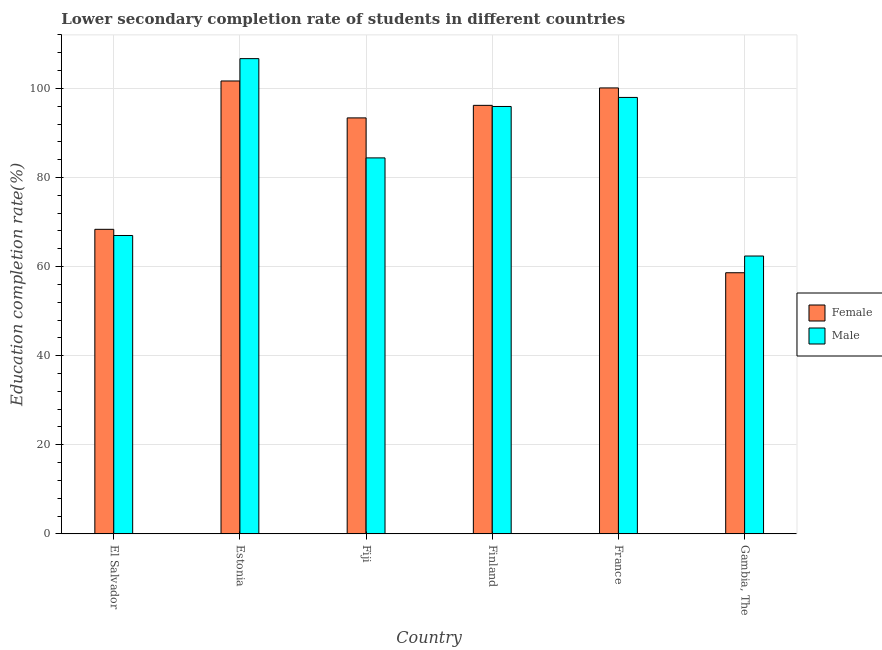How many groups of bars are there?
Offer a terse response. 6. Are the number of bars on each tick of the X-axis equal?
Your answer should be very brief. Yes. How many bars are there on the 1st tick from the left?
Ensure brevity in your answer.  2. What is the label of the 5th group of bars from the left?
Provide a succinct answer. France. What is the education completion rate of female students in France?
Make the answer very short. 100.12. Across all countries, what is the maximum education completion rate of male students?
Your response must be concise. 106.69. Across all countries, what is the minimum education completion rate of male students?
Make the answer very short. 62.38. In which country was the education completion rate of male students maximum?
Keep it short and to the point. Estonia. In which country was the education completion rate of male students minimum?
Make the answer very short. Gambia, The. What is the total education completion rate of female students in the graph?
Make the answer very short. 518.38. What is the difference between the education completion rate of male students in Finland and that in France?
Give a very brief answer. -2.03. What is the difference between the education completion rate of male students in Estonia and the education completion rate of female students in Finland?
Offer a terse response. 10.49. What is the average education completion rate of male students per country?
Ensure brevity in your answer.  85.73. What is the difference between the education completion rate of female students and education completion rate of male students in Fiji?
Ensure brevity in your answer.  8.98. What is the ratio of the education completion rate of male students in El Salvador to that in Estonia?
Keep it short and to the point. 0.63. Is the difference between the education completion rate of male students in Fiji and France greater than the difference between the education completion rate of female students in Fiji and France?
Make the answer very short. No. What is the difference between the highest and the second highest education completion rate of female students?
Provide a succinct answer. 1.56. What is the difference between the highest and the lowest education completion rate of female students?
Keep it short and to the point. 43.05. Is the sum of the education completion rate of male students in Fiji and Gambia, The greater than the maximum education completion rate of female students across all countries?
Make the answer very short. Yes. What does the 2nd bar from the left in France represents?
Offer a very short reply. Male. How many bars are there?
Provide a succinct answer. 12. Are all the bars in the graph horizontal?
Offer a terse response. No. How many countries are there in the graph?
Offer a terse response. 6. Are the values on the major ticks of Y-axis written in scientific E-notation?
Make the answer very short. No. Does the graph contain grids?
Your answer should be compact. Yes. Where does the legend appear in the graph?
Your answer should be very brief. Center right. How many legend labels are there?
Provide a short and direct response. 2. What is the title of the graph?
Provide a succinct answer. Lower secondary completion rate of students in different countries. What is the label or title of the X-axis?
Your answer should be very brief. Country. What is the label or title of the Y-axis?
Give a very brief answer. Education completion rate(%). What is the Education completion rate(%) in Female in El Salvador?
Offer a very short reply. 68.37. What is the Education completion rate(%) of Male in El Salvador?
Your answer should be very brief. 66.99. What is the Education completion rate(%) in Female in Estonia?
Offer a very short reply. 101.68. What is the Education completion rate(%) of Male in Estonia?
Ensure brevity in your answer.  106.69. What is the Education completion rate(%) in Female in Fiji?
Provide a succinct answer. 93.39. What is the Education completion rate(%) of Male in Fiji?
Offer a very short reply. 84.41. What is the Education completion rate(%) of Female in Finland?
Your answer should be compact. 96.21. What is the Education completion rate(%) of Male in Finland?
Your answer should be very brief. 95.95. What is the Education completion rate(%) in Female in France?
Make the answer very short. 100.12. What is the Education completion rate(%) in Male in France?
Offer a terse response. 97.98. What is the Education completion rate(%) of Female in Gambia, The?
Your answer should be very brief. 58.62. What is the Education completion rate(%) in Male in Gambia, The?
Offer a very short reply. 62.38. Across all countries, what is the maximum Education completion rate(%) in Female?
Your answer should be very brief. 101.68. Across all countries, what is the maximum Education completion rate(%) of Male?
Offer a very short reply. 106.69. Across all countries, what is the minimum Education completion rate(%) of Female?
Keep it short and to the point. 58.62. Across all countries, what is the minimum Education completion rate(%) of Male?
Your answer should be very brief. 62.38. What is the total Education completion rate(%) in Female in the graph?
Give a very brief answer. 518.38. What is the total Education completion rate(%) in Male in the graph?
Make the answer very short. 514.4. What is the difference between the Education completion rate(%) in Female in El Salvador and that in Estonia?
Your response must be concise. -33.3. What is the difference between the Education completion rate(%) of Male in El Salvador and that in Estonia?
Make the answer very short. -39.71. What is the difference between the Education completion rate(%) in Female in El Salvador and that in Fiji?
Provide a succinct answer. -25.01. What is the difference between the Education completion rate(%) in Male in El Salvador and that in Fiji?
Provide a succinct answer. -17.42. What is the difference between the Education completion rate(%) in Female in El Salvador and that in Finland?
Ensure brevity in your answer.  -27.83. What is the difference between the Education completion rate(%) of Male in El Salvador and that in Finland?
Offer a terse response. -28.96. What is the difference between the Education completion rate(%) in Female in El Salvador and that in France?
Your response must be concise. -31.74. What is the difference between the Education completion rate(%) of Male in El Salvador and that in France?
Make the answer very short. -31. What is the difference between the Education completion rate(%) in Female in El Salvador and that in Gambia, The?
Provide a succinct answer. 9.75. What is the difference between the Education completion rate(%) in Male in El Salvador and that in Gambia, The?
Your answer should be very brief. 4.61. What is the difference between the Education completion rate(%) of Female in Estonia and that in Fiji?
Ensure brevity in your answer.  8.29. What is the difference between the Education completion rate(%) of Male in Estonia and that in Fiji?
Ensure brevity in your answer.  22.28. What is the difference between the Education completion rate(%) in Female in Estonia and that in Finland?
Your answer should be compact. 5.47. What is the difference between the Education completion rate(%) of Male in Estonia and that in Finland?
Your answer should be very brief. 10.74. What is the difference between the Education completion rate(%) in Female in Estonia and that in France?
Offer a terse response. 1.56. What is the difference between the Education completion rate(%) of Male in Estonia and that in France?
Provide a succinct answer. 8.71. What is the difference between the Education completion rate(%) in Female in Estonia and that in Gambia, The?
Your response must be concise. 43.05. What is the difference between the Education completion rate(%) of Male in Estonia and that in Gambia, The?
Your response must be concise. 44.32. What is the difference between the Education completion rate(%) in Female in Fiji and that in Finland?
Offer a terse response. -2.82. What is the difference between the Education completion rate(%) of Male in Fiji and that in Finland?
Offer a terse response. -11.54. What is the difference between the Education completion rate(%) of Female in Fiji and that in France?
Your answer should be compact. -6.73. What is the difference between the Education completion rate(%) of Male in Fiji and that in France?
Give a very brief answer. -13.58. What is the difference between the Education completion rate(%) in Female in Fiji and that in Gambia, The?
Give a very brief answer. 34.76. What is the difference between the Education completion rate(%) in Male in Fiji and that in Gambia, The?
Provide a succinct answer. 22.03. What is the difference between the Education completion rate(%) of Female in Finland and that in France?
Give a very brief answer. -3.91. What is the difference between the Education completion rate(%) in Male in Finland and that in France?
Offer a very short reply. -2.03. What is the difference between the Education completion rate(%) in Female in Finland and that in Gambia, The?
Make the answer very short. 37.58. What is the difference between the Education completion rate(%) of Male in Finland and that in Gambia, The?
Your response must be concise. 33.58. What is the difference between the Education completion rate(%) of Female in France and that in Gambia, The?
Provide a short and direct response. 41.49. What is the difference between the Education completion rate(%) in Male in France and that in Gambia, The?
Offer a terse response. 35.61. What is the difference between the Education completion rate(%) in Female in El Salvador and the Education completion rate(%) in Male in Estonia?
Provide a short and direct response. -38.32. What is the difference between the Education completion rate(%) of Female in El Salvador and the Education completion rate(%) of Male in Fiji?
Your answer should be compact. -16.04. What is the difference between the Education completion rate(%) in Female in El Salvador and the Education completion rate(%) in Male in Finland?
Give a very brief answer. -27.58. What is the difference between the Education completion rate(%) in Female in El Salvador and the Education completion rate(%) in Male in France?
Offer a terse response. -29.61. What is the difference between the Education completion rate(%) of Female in El Salvador and the Education completion rate(%) of Male in Gambia, The?
Ensure brevity in your answer.  6. What is the difference between the Education completion rate(%) in Female in Estonia and the Education completion rate(%) in Male in Fiji?
Make the answer very short. 17.27. What is the difference between the Education completion rate(%) of Female in Estonia and the Education completion rate(%) of Male in Finland?
Keep it short and to the point. 5.72. What is the difference between the Education completion rate(%) of Female in Estonia and the Education completion rate(%) of Male in France?
Offer a very short reply. 3.69. What is the difference between the Education completion rate(%) of Female in Estonia and the Education completion rate(%) of Male in Gambia, The?
Give a very brief answer. 39.3. What is the difference between the Education completion rate(%) in Female in Fiji and the Education completion rate(%) in Male in Finland?
Ensure brevity in your answer.  -2.57. What is the difference between the Education completion rate(%) in Female in Fiji and the Education completion rate(%) in Male in France?
Give a very brief answer. -4.6. What is the difference between the Education completion rate(%) of Female in Fiji and the Education completion rate(%) of Male in Gambia, The?
Ensure brevity in your answer.  31.01. What is the difference between the Education completion rate(%) in Female in Finland and the Education completion rate(%) in Male in France?
Ensure brevity in your answer.  -1.78. What is the difference between the Education completion rate(%) of Female in Finland and the Education completion rate(%) of Male in Gambia, The?
Ensure brevity in your answer.  33.83. What is the difference between the Education completion rate(%) in Female in France and the Education completion rate(%) in Male in Gambia, The?
Keep it short and to the point. 37.74. What is the average Education completion rate(%) of Female per country?
Offer a terse response. 86.4. What is the average Education completion rate(%) in Male per country?
Your answer should be very brief. 85.73. What is the difference between the Education completion rate(%) in Female and Education completion rate(%) in Male in El Salvador?
Your answer should be very brief. 1.39. What is the difference between the Education completion rate(%) of Female and Education completion rate(%) of Male in Estonia?
Offer a terse response. -5.02. What is the difference between the Education completion rate(%) in Female and Education completion rate(%) in Male in Fiji?
Keep it short and to the point. 8.98. What is the difference between the Education completion rate(%) in Female and Education completion rate(%) in Male in Finland?
Give a very brief answer. 0.25. What is the difference between the Education completion rate(%) in Female and Education completion rate(%) in Male in France?
Offer a terse response. 2.13. What is the difference between the Education completion rate(%) of Female and Education completion rate(%) of Male in Gambia, The?
Make the answer very short. -3.75. What is the ratio of the Education completion rate(%) in Female in El Salvador to that in Estonia?
Provide a succinct answer. 0.67. What is the ratio of the Education completion rate(%) of Male in El Salvador to that in Estonia?
Provide a short and direct response. 0.63. What is the ratio of the Education completion rate(%) of Female in El Salvador to that in Fiji?
Provide a succinct answer. 0.73. What is the ratio of the Education completion rate(%) in Male in El Salvador to that in Fiji?
Your answer should be very brief. 0.79. What is the ratio of the Education completion rate(%) of Female in El Salvador to that in Finland?
Keep it short and to the point. 0.71. What is the ratio of the Education completion rate(%) of Male in El Salvador to that in Finland?
Offer a terse response. 0.7. What is the ratio of the Education completion rate(%) in Female in El Salvador to that in France?
Offer a terse response. 0.68. What is the ratio of the Education completion rate(%) of Male in El Salvador to that in France?
Keep it short and to the point. 0.68. What is the ratio of the Education completion rate(%) of Female in El Salvador to that in Gambia, The?
Your answer should be very brief. 1.17. What is the ratio of the Education completion rate(%) in Male in El Salvador to that in Gambia, The?
Keep it short and to the point. 1.07. What is the ratio of the Education completion rate(%) in Female in Estonia to that in Fiji?
Your response must be concise. 1.09. What is the ratio of the Education completion rate(%) in Male in Estonia to that in Fiji?
Your answer should be very brief. 1.26. What is the ratio of the Education completion rate(%) in Female in Estonia to that in Finland?
Ensure brevity in your answer.  1.06. What is the ratio of the Education completion rate(%) in Male in Estonia to that in Finland?
Your answer should be compact. 1.11. What is the ratio of the Education completion rate(%) in Female in Estonia to that in France?
Your answer should be compact. 1.02. What is the ratio of the Education completion rate(%) of Male in Estonia to that in France?
Provide a short and direct response. 1.09. What is the ratio of the Education completion rate(%) in Female in Estonia to that in Gambia, The?
Your answer should be compact. 1.73. What is the ratio of the Education completion rate(%) of Male in Estonia to that in Gambia, The?
Your response must be concise. 1.71. What is the ratio of the Education completion rate(%) of Female in Fiji to that in Finland?
Your answer should be very brief. 0.97. What is the ratio of the Education completion rate(%) of Male in Fiji to that in Finland?
Ensure brevity in your answer.  0.88. What is the ratio of the Education completion rate(%) of Female in Fiji to that in France?
Make the answer very short. 0.93. What is the ratio of the Education completion rate(%) of Male in Fiji to that in France?
Your answer should be compact. 0.86. What is the ratio of the Education completion rate(%) of Female in Fiji to that in Gambia, The?
Keep it short and to the point. 1.59. What is the ratio of the Education completion rate(%) of Male in Fiji to that in Gambia, The?
Your answer should be compact. 1.35. What is the ratio of the Education completion rate(%) in Female in Finland to that in France?
Your answer should be compact. 0.96. What is the ratio of the Education completion rate(%) in Male in Finland to that in France?
Make the answer very short. 0.98. What is the ratio of the Education completion rate(%) of Female in Finland to that in Gambia, The?
Ensure brevity in your answer.  1.64. What is the ratio of the Education completion rate(%) in Male in Finland to that in Gambia, The?
Your response must be concise. 1.54. What is the ratio of the Education completion rate(%) in Female in France to that in Gambia, The?
Give a very brief answer. 1.71. What is the ratio of the Education completion rate(%) of Male in France to that in Gambia, The?
Give a very brief answer. 1.57. What is the difference between the highest and the second highest Education completion rate(%) in Female?
Offer a terse response. 1.56. What is the difference between the highest and the second highest Education completion rate(%) of Male?
Offer a very short reply. 8.71. What is the difference between the highest and the lowest Education completion rate(%) of Female?
Give a very brief answer. 43.05. What is the difference between the highest and the lowest Education completion rate(%) in Male?
Ensure brevity in your answer.  44.32. 